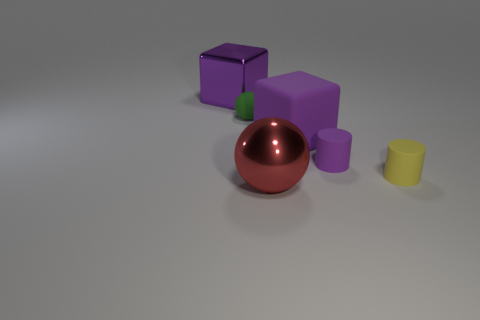Add 4 tiny matte objects. How many objects exist? 10 Subtract all balls. How many objects are left? 4 Add 4 small matte cylinders. How many small matte cylinders exist? 6 Subtract 0 red cubes. How many objects are left? 6 Subtract all large blue spheres. Subtract all purple rubber cylinders. How many objects are left? 5 Add 1 small things. How many small things are left? 4 